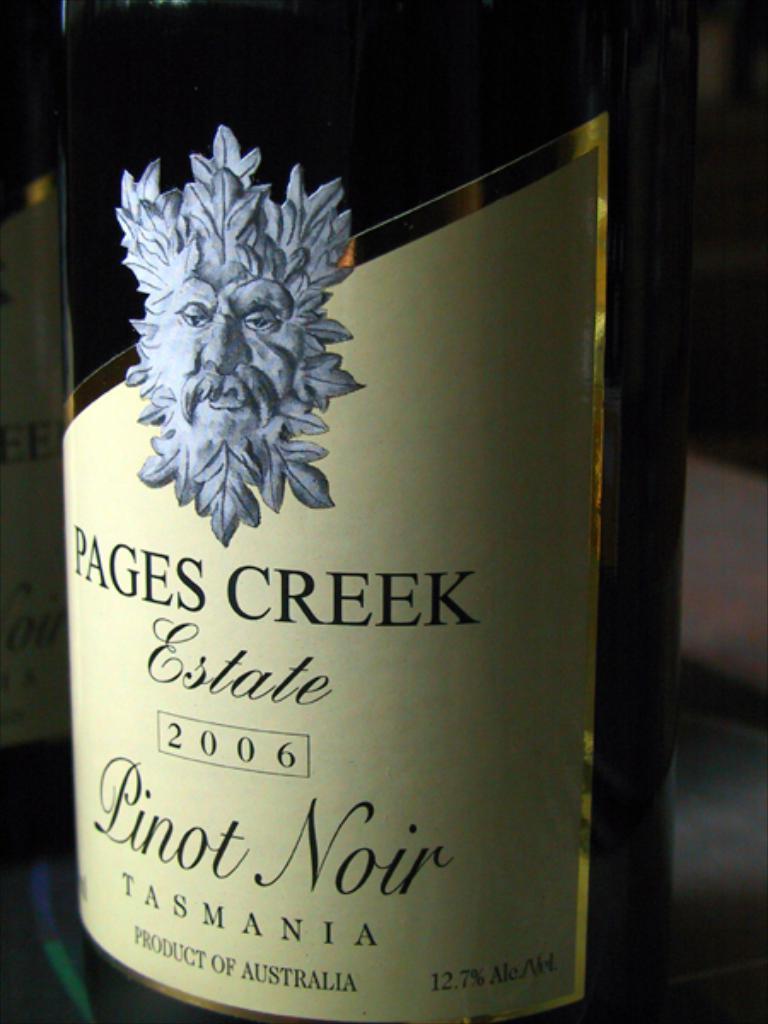What type of wine is this?
Your answer should be very brief. Pinot noir. What year was this wine made?
Keep it short and to the point. 2006. 